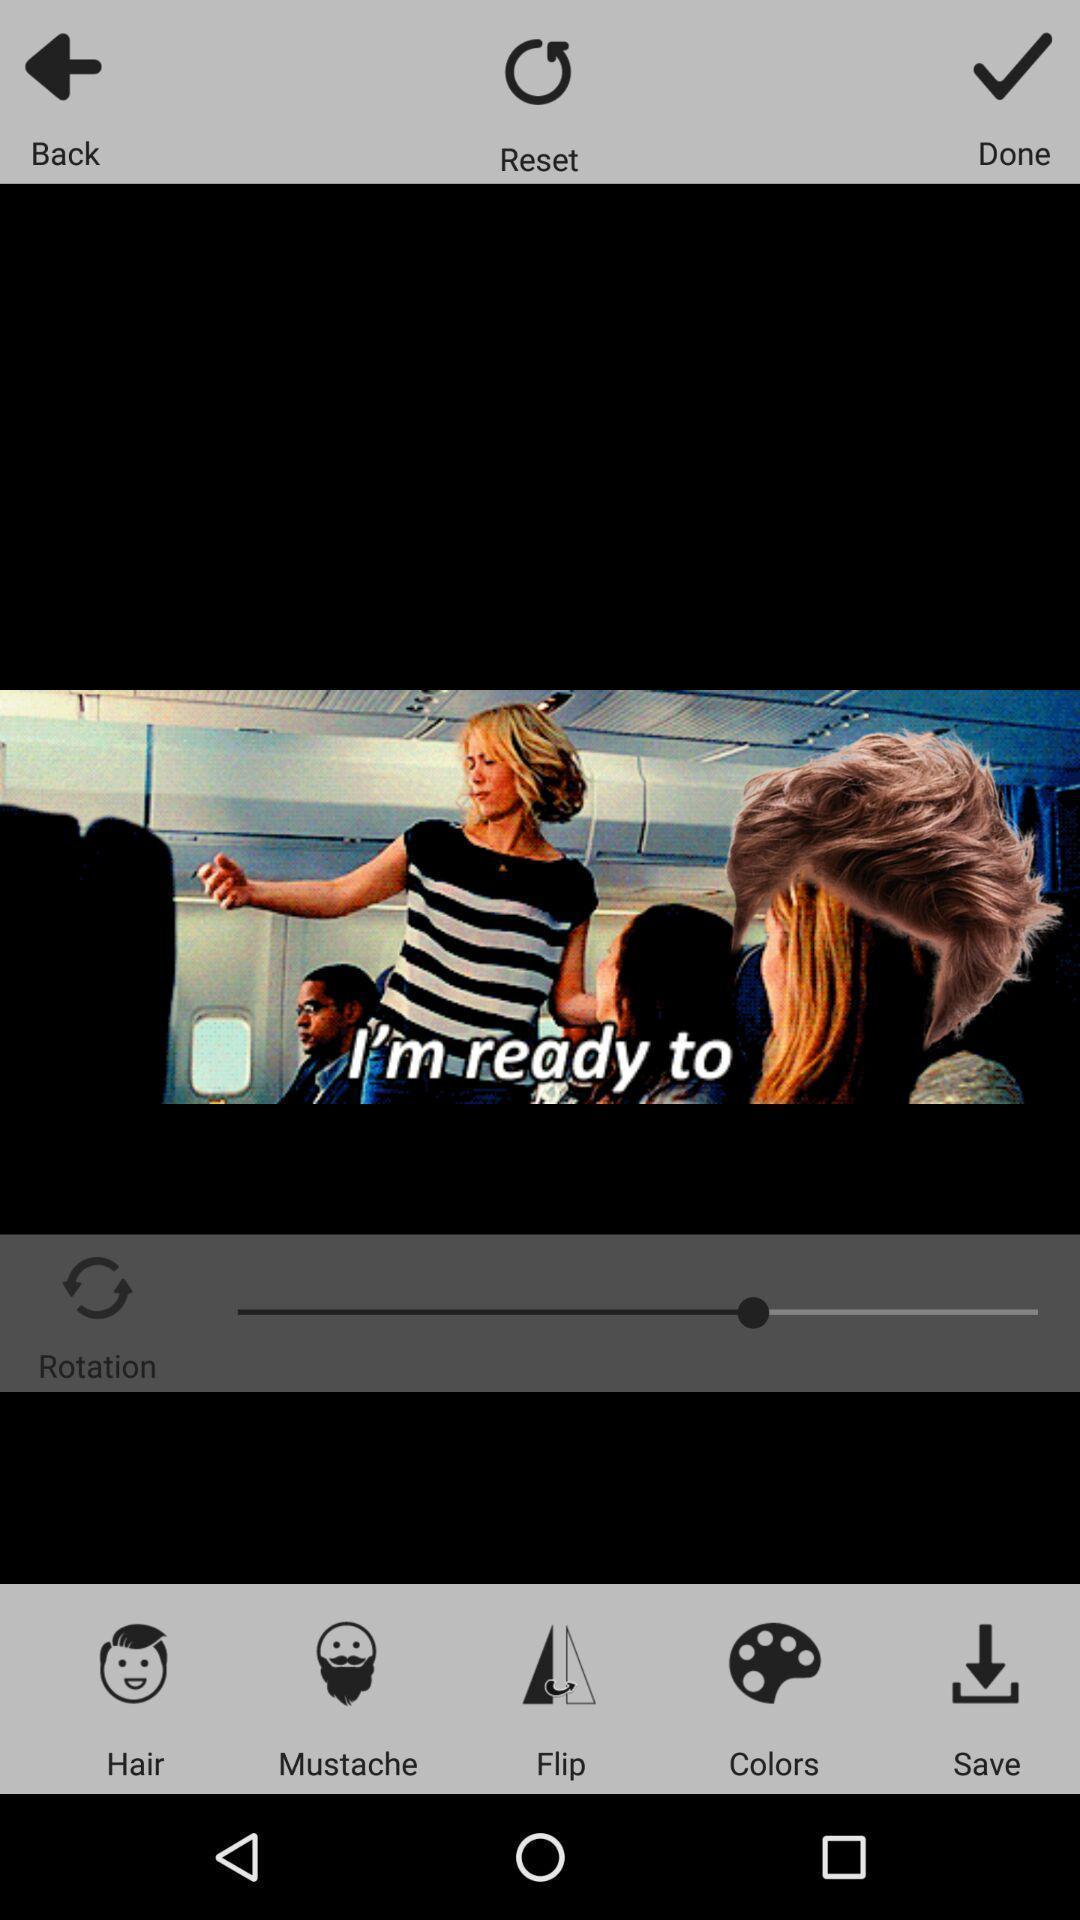Describe the visual elements of this screenshot. Showing the back reset and done options. 